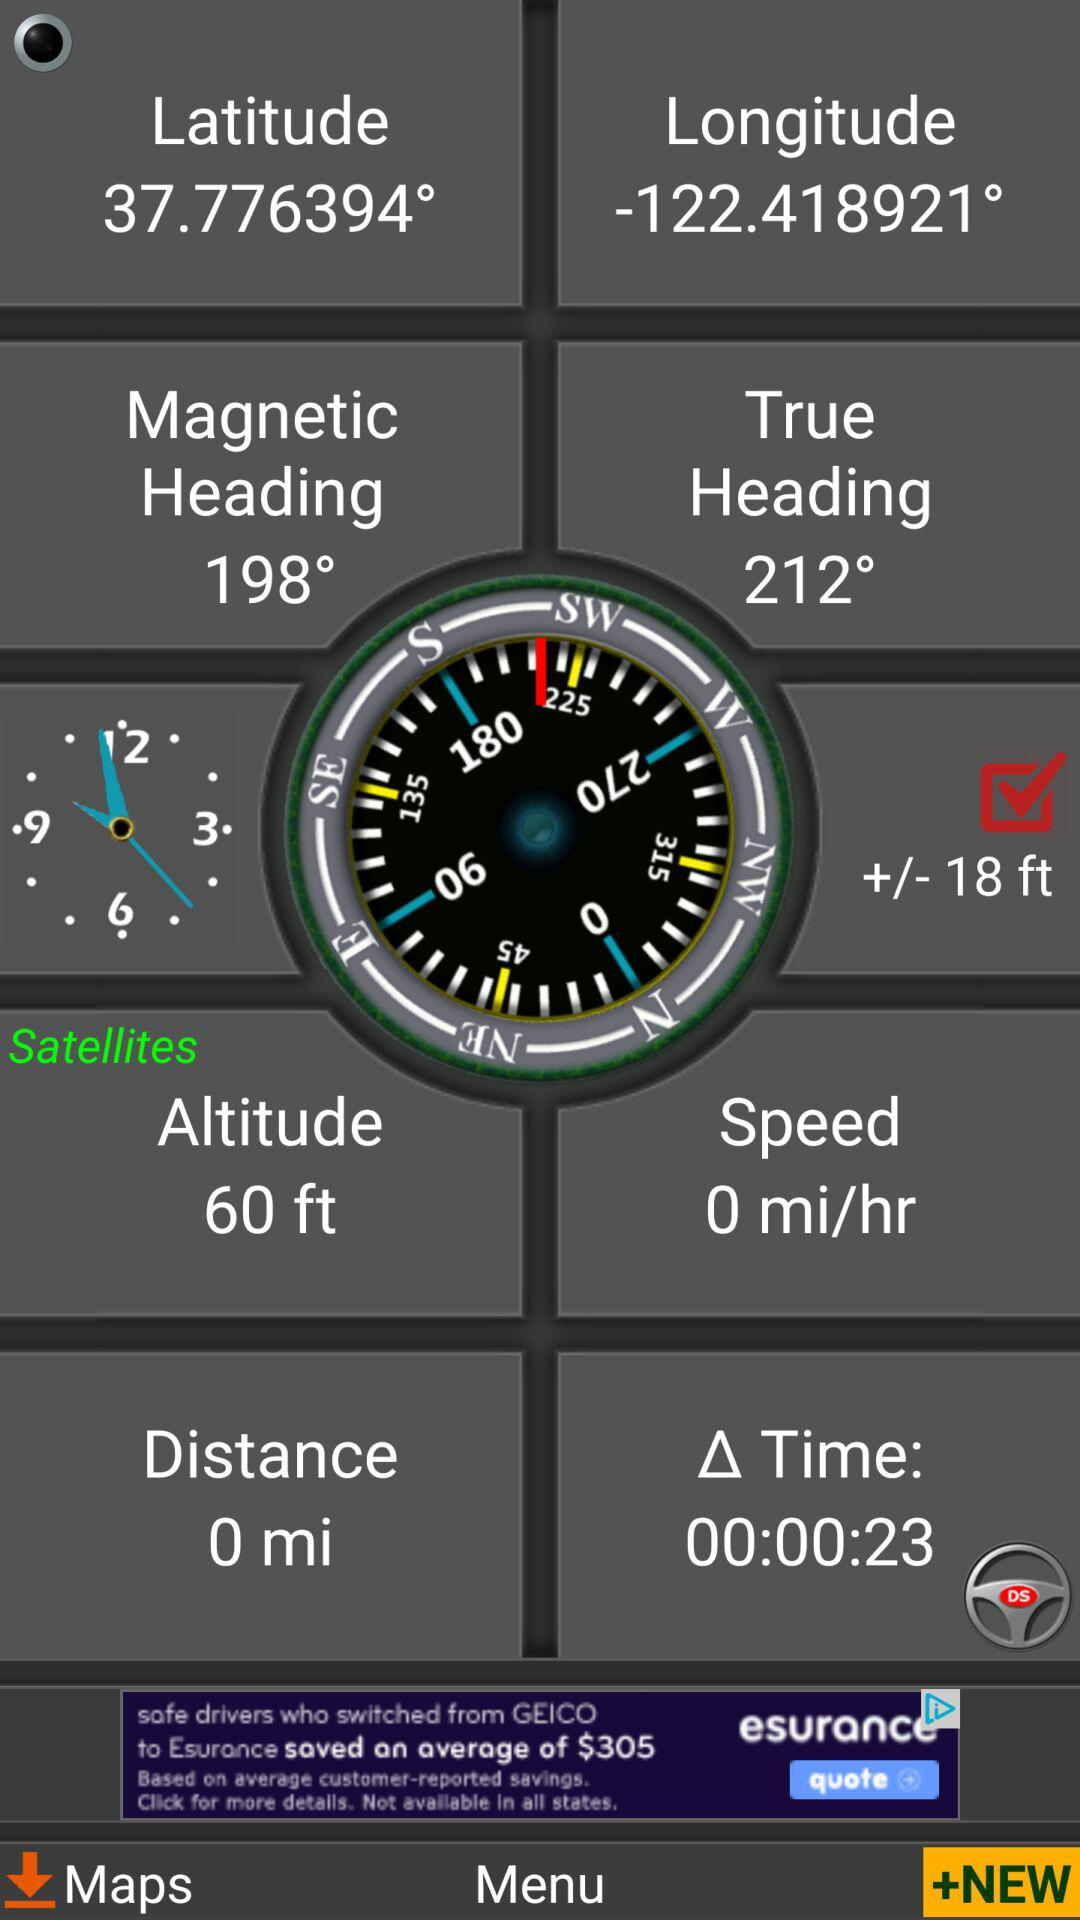What is the altitude in "Satellites"? The altitude in "Satellites" is 60 feet. 